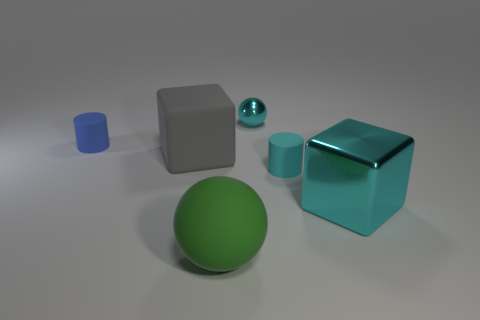Subtract 2 balls. How many balls are left? 0 Add 2 small purple shiny objects. How many objects exist? 8 Subtract all balls. How many objects are left? 4 Subtract all blue balls. How many blue cylinders are left? 1 Subtract 1 cyan cylinders. How many objects are left? 5 Subtract all gray cylinders. Subtract all red spheres. How many cylinders are left? 2 Subtract all big gray objects. Subtract all rubber cylinders. How many objects are left? 3 Add 2 shiny things. How many shiny things are left? 4 Add 4 shiny blocks. How many shiny blocks exist? 5 